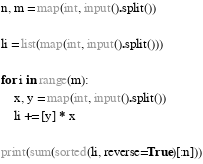<code> <loc_0><loc_0><loc_500><loc_500><_Python_>n, m = map(int, input().split())

li = list(map(int, input().split()))

for i in range(m):
    x, y = map(int, input().split())
    li += [y] * x

print(sum(sorted(li, reverse=True)[:n]))</code> 